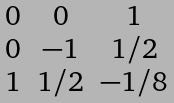<formula> <loc_0><loc_0><loc_500><loc_500>\begin{matrix} 0 & 0 & 1 \\ 0 & - 1 & 1 / 2 \\ 1 & 1 / 2 & - 1 / 8 \end{matrix}</formula> 